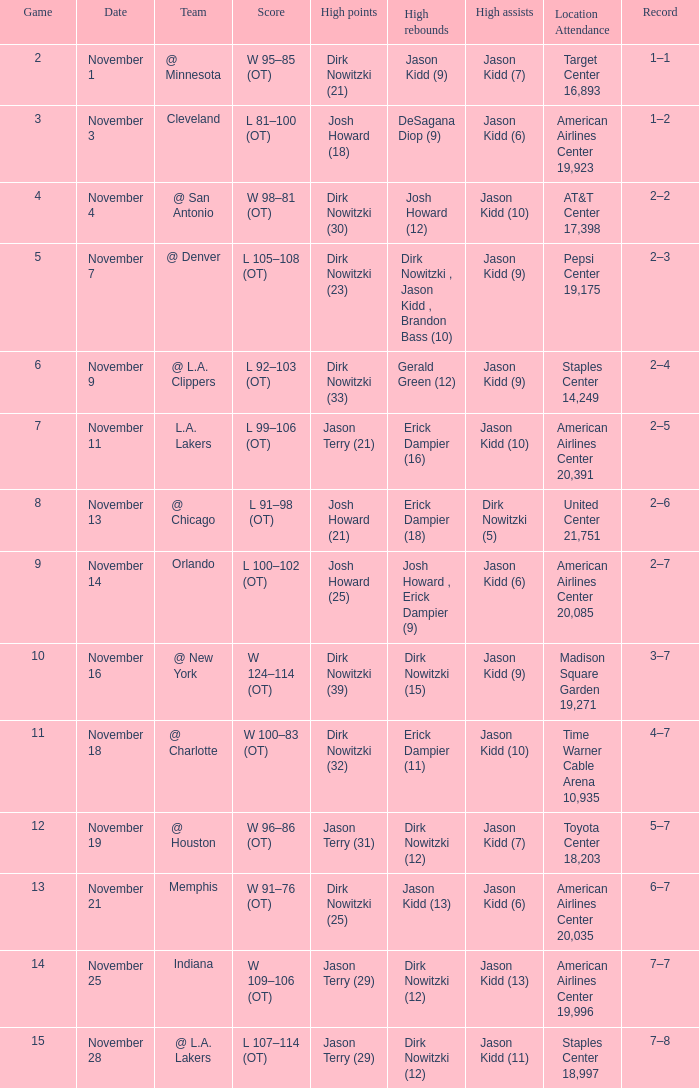What was the milestone on november 7? 1.0. 